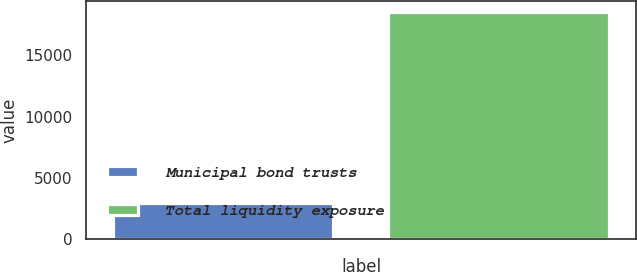Convert chart. <chart><loc_0><loc_0><loc_500><loc_500><bar_chart><fcel>Municipal bond trusts<fcel>Total liquidity exposure<nl><fcel>2921<fcel>18509<nl></chart> 